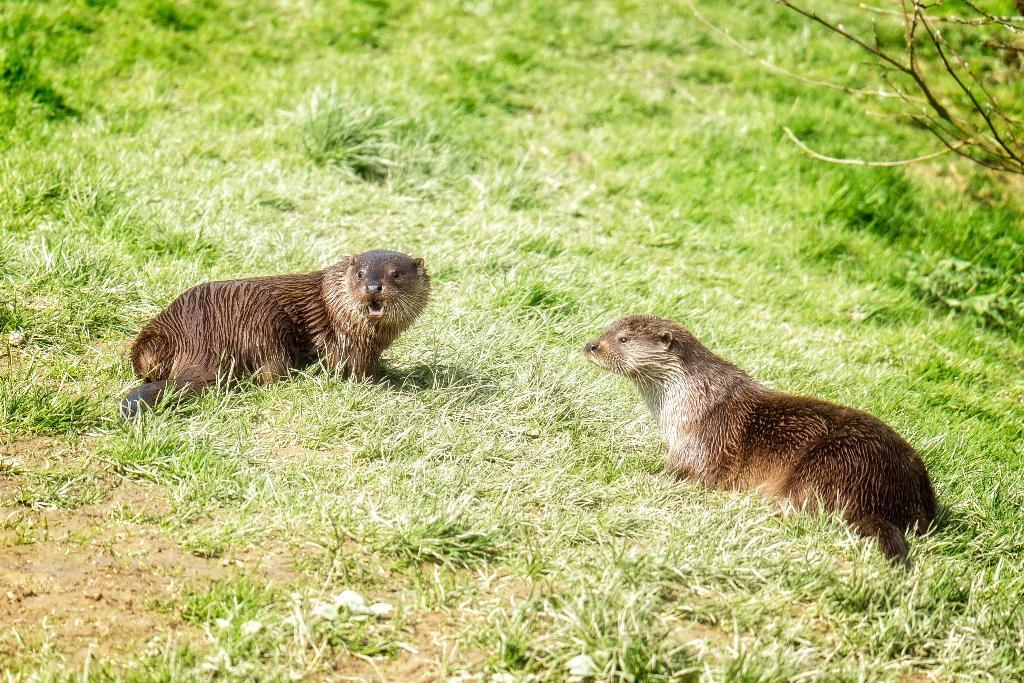Please provide a concise description of this image. In this picture we can see animals, grass and branches. 